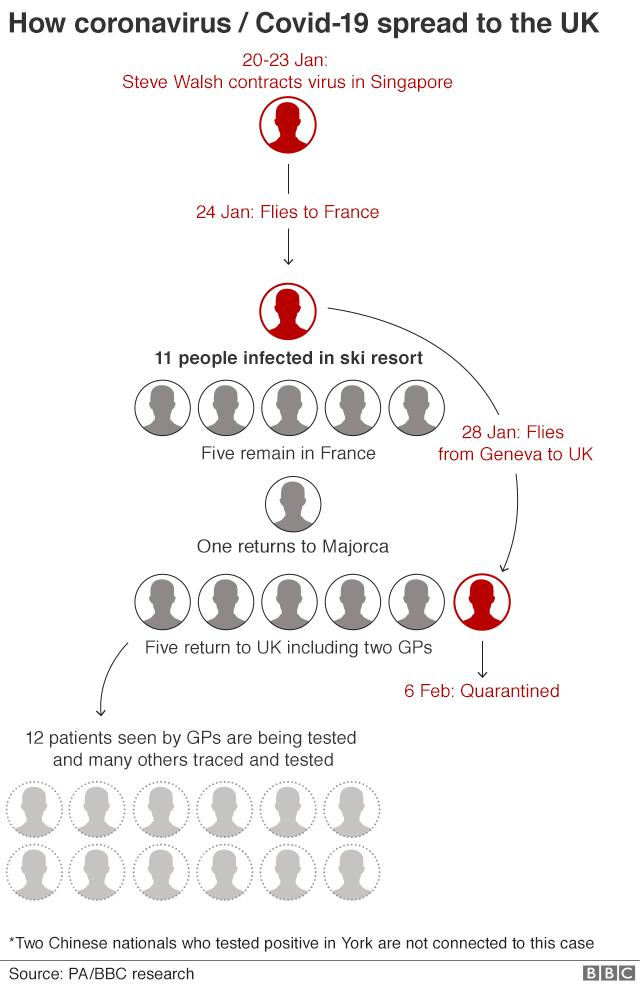Highlight a few significant elements in this photo. On February 6th, a significant number of individuals were placed in quarantine as a precautionary measure. 